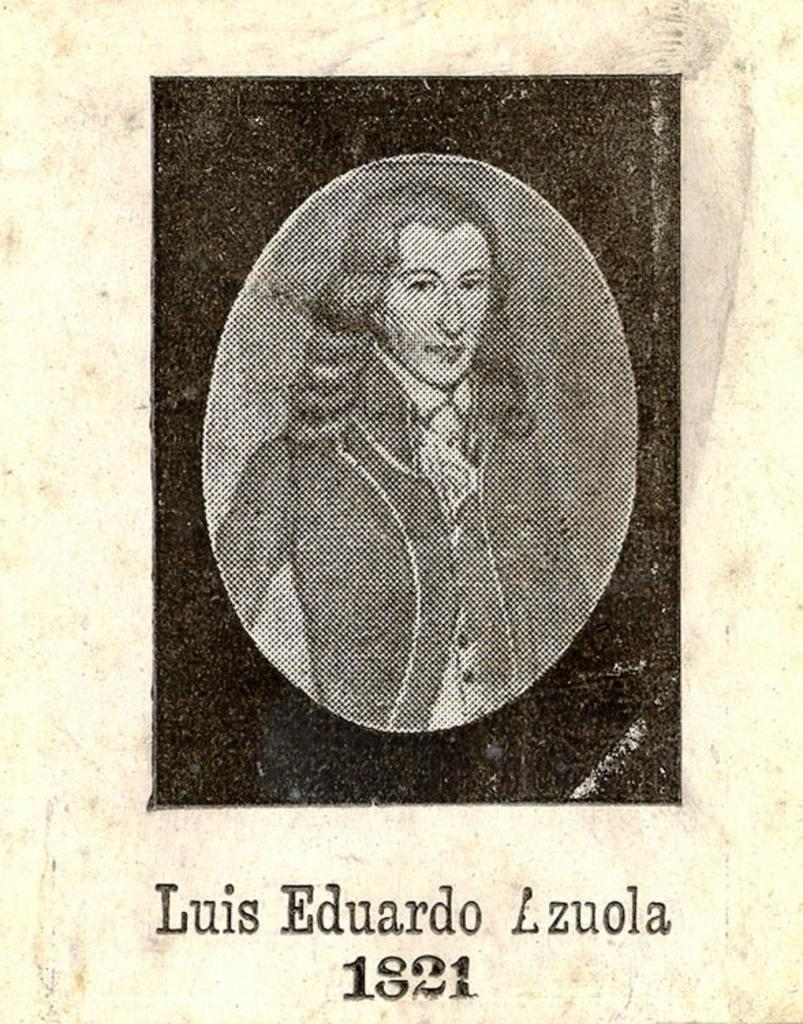What is the main subject of the image? There is a photo of a person in the image. Can you describe any additional elements in the image? There is text written at the bottom of the image. What time of day is depicted in the image? The time of day is not depicted in the image, as it only contains a photo of a person and text at the bottom. 